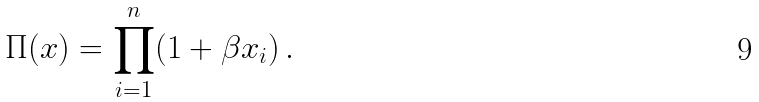Convert formula to latex. <formula><loc_0><loc_0><loc_500><loc_500>\Pi ( x ) = \prod _ { i = 1 } ^ { n } ( 1 + \beta x _ { i } ) \, .</formula> 